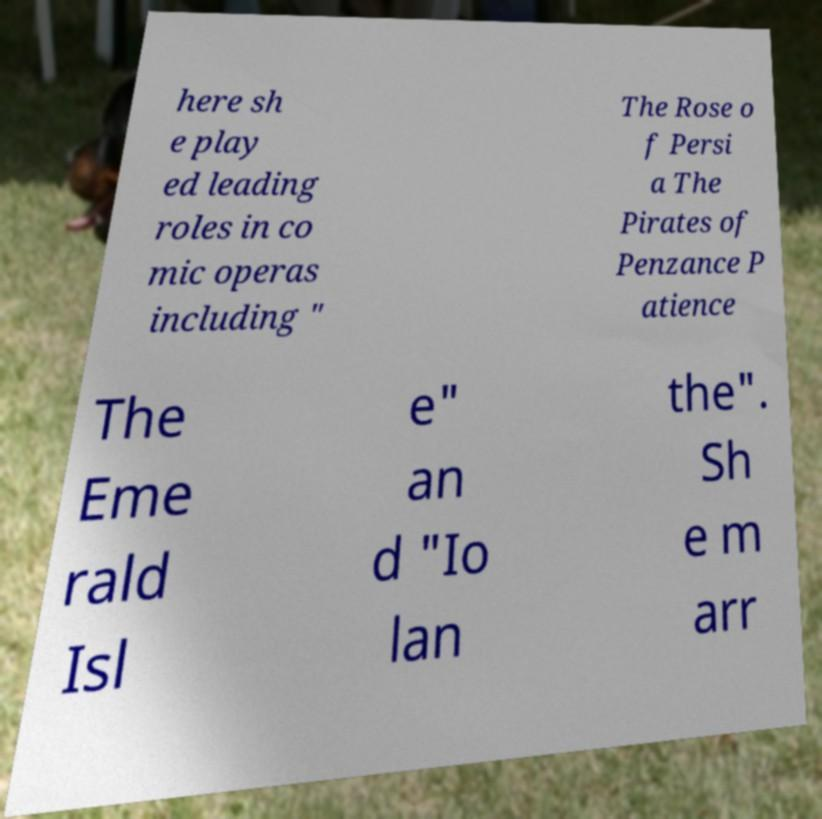What messages or text are displayed in this image? I need them in a readable, typed format. here sh e play ed leading roles in co mic operas including " The Rose o f Persi a The Pirates of Penzance P atience The Eme rald Isl e" an d "Io lan the". Sh e m arr 